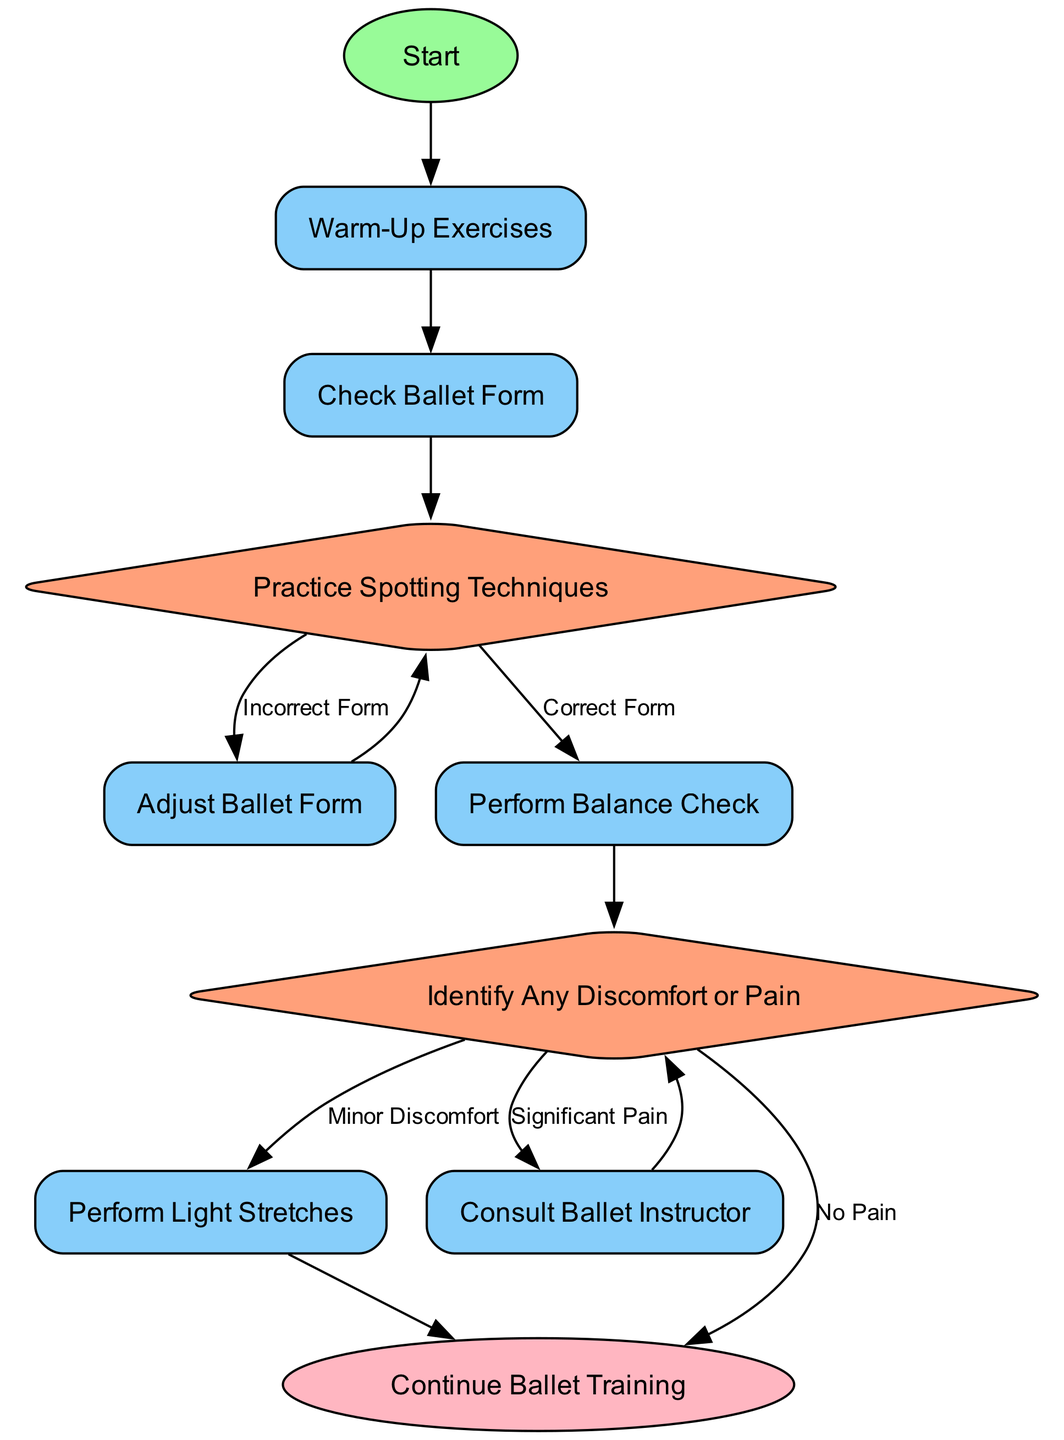What is the starting activity in the diagram? The diagram begins with the node labeled "Start," which indicates the initiation of the process.
Answer: Start How many decision nodes are present in the diagram? The diagram has two decision nodes: "Spotting Techniques" and "Identify Any Discomfort or Pain," indicating points where choices are made.
Answer: 2 What is the last activity before reaching the end node? The last activity that leads to the end node is "Continue Ballet Training," which signifies that the process is successfully completed.
Answer: Continue Ballet Training Which activity follows "Check Ballet Form"? Following "Check Ballet Form," the next activity in sequence is "Practice Spotting Techniques," indicating the progression of the training steps.
Answer: Practice Spotting Techniques What happens if "Significant Pain" is identified? If "Significant Pain" is identified, the diagram directs the process to "Consult Ballet Instructor," reflecting the need for expert guidance in this situation.
Answer: Consult Ballet Instructor If the ballet form is correct, what activity occurs next? If the ballet form is correct after checking, the activity that occurs next is "Perform Balance Check," representing the continuation of training after verification.
Answer: Perform Balance Check What is the first activity after warming up? After completing the "Warm-Up Exercises," the first activity to be done is "Check Ballet Form" as part of the training routine.
Answer: Check Ballet Form What is the consequence of performing light stretches? The consequence of performing "Light Stretches" is that it leads directly to "Continue Ballet Training," allowing the dancer to resume practice.
Answer: Continue Ballet Training 